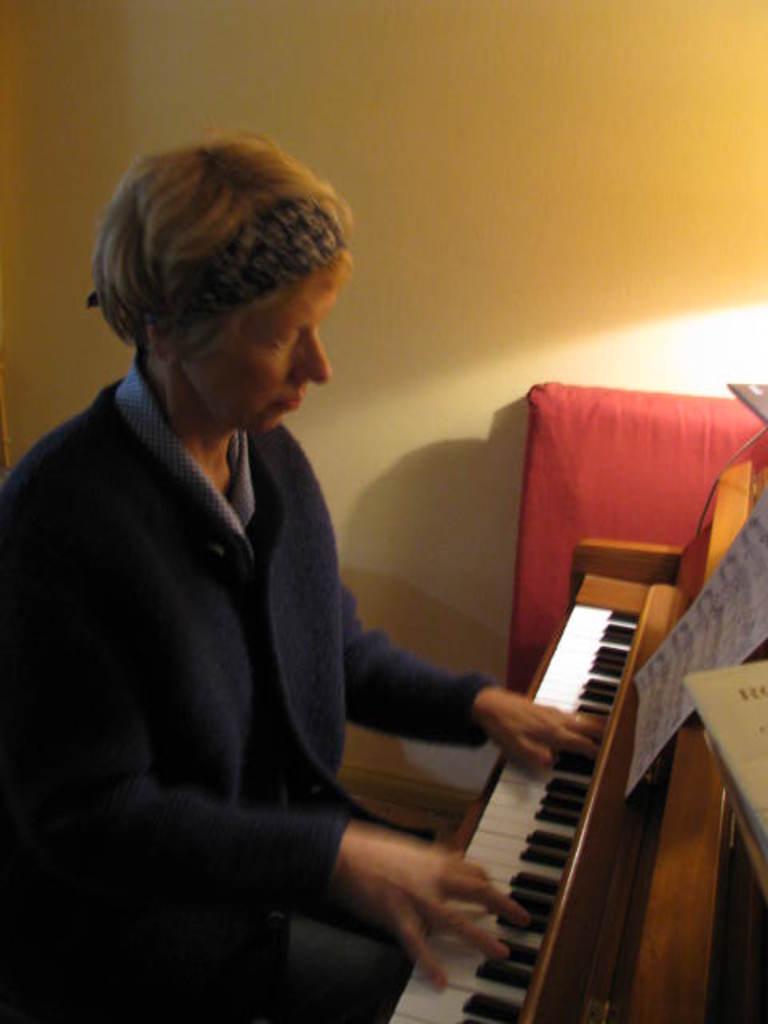In one or two sentences, can you explain what this image depicts? In this image there is a person sitting and playing a piano , and a paper and the back ground there is a wall. 